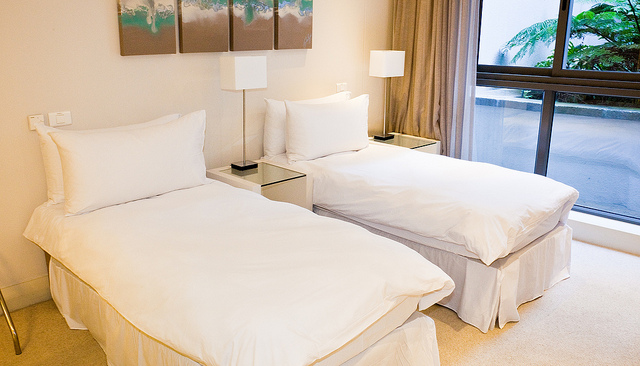How many beds are there? There are 2 beds in the room, both neatly made with white linens and positioned parallel to each other, each with its own bedside table and lamp. 